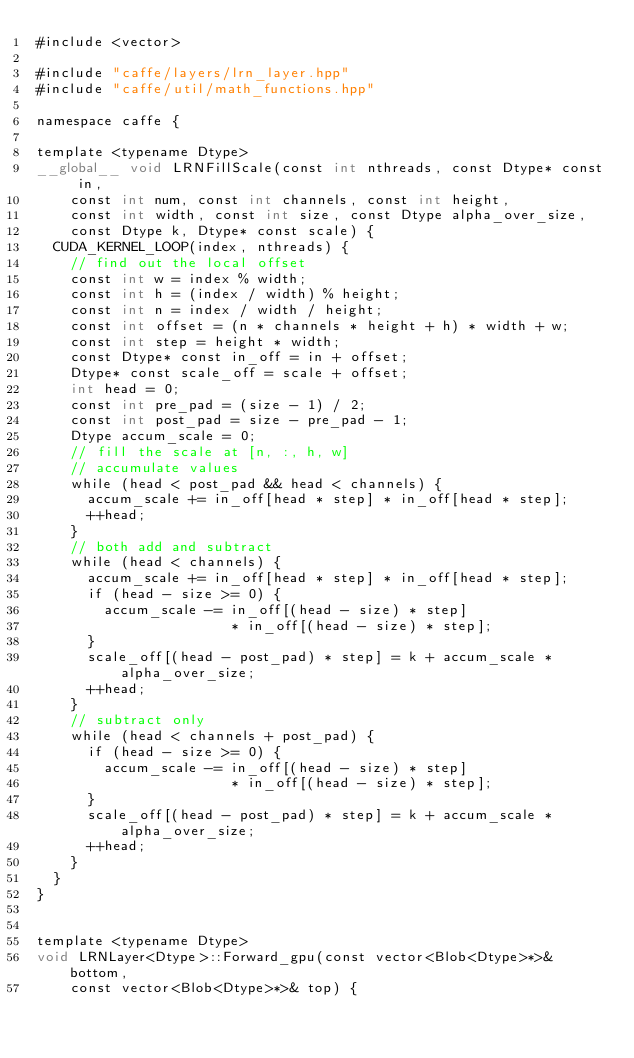Convert code to text. <code><loc_0><loc_0><loc_500><loc_500><_Cuda_>#include <vector>

#include "caffe/layers/lrn_layer.hpp"
#include "caffe/util/math_functions.hpp"

namespace caffe {

template <typename Dtype>
__global__ void LRNFillScale(const int nthreads, const Dtype* const in,
    const int num, const int channels, const int height,
    const int width, const int size, const Dtype alpha_over_size,
    const Dtype k, Dtype* const scale) {
  CUDA_KERNEL_LOOP(index, nthreads) {
    // find out the local offset
    const int w = index % width;
    const int h = (index / width) % height;
    const int n = index / width / height;
    const int offset = (n * channels * height + h) * width + w;
    const int step = height * width;
    const Dtype* const in_off = in + offset;
    Dtype* const scale_off = scale + offset;
    int head = 0;
    const int pre_pad = (size - 1) / 2;
    const int post_pad = size - pre_pad - 1;
    Dtype accum_scale = 0;
    // fill the scale at [n, :, h, w]
    // accumulate values
    while (head < post_pad && head < channels) {
      accum_scale += in_off[head * step] * in_off[head * step];
      ++head;
    }
    // both add and subtract
    while (head < channels) {
      accum_scale += in_off[head * step] * in_off[head * step];
      if (head - size >= 0) {
        accum_scale -= in_off[(head - size) * step]
                       * in_off[(head - size) * step];
      }
      scale_off[(head - post_pad) * step] = k + accum_scale * alpha_over_size;
      ++head;
    }
    // subtract only
    while (head < channels + post_pad) {
      if (head - size >= 0) {
        accum_scale -= in_off[(head - size) * step]
                       * in_off[(head - size) * step];
      }
      scale_off[(head - post_pad) * step] = k + accum_scale * alpha_over_size;
      ++head;
    }
  }
}


template <typename Dtype>
void LRNLayer<Dtype>::Forward_gpu(const vector<Blob<Dtype>*>& bottom,
    const vector<Blob<Dtype>*>& top) {</code> 